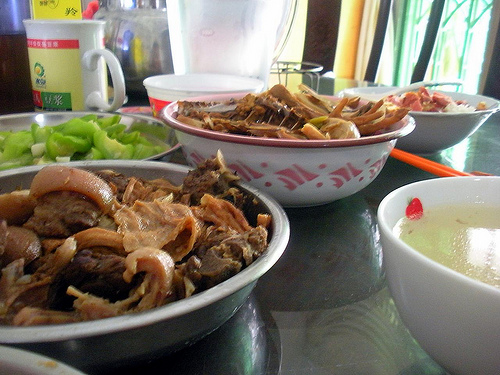<image>
Is the food in the bowl? Yes. The food is contained within or inside the bowl, showing a containment relationship. Where is the meat in relation to the bowl? Is it in the bowl? Yes. The meat is contained within or inside the bowl, showing a containment relationship. 